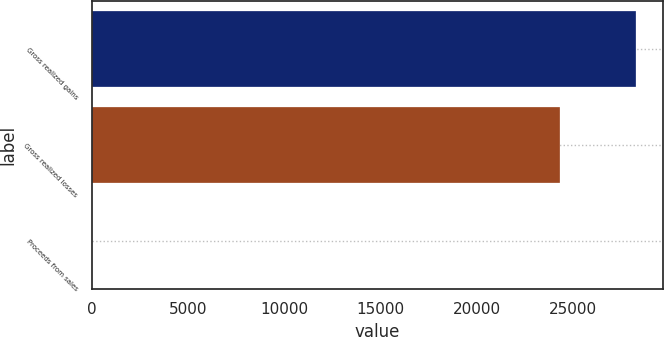Convert chart. <chart><loc_0><loc_0><loc_500><loc_500><bar_chart><fcel>Gross realized gains<fcel>Gross realized losses<fcel>Proceeds from sales<nl><fcel>28249<fcel>24323<fcel>0.18<nl></chart> 